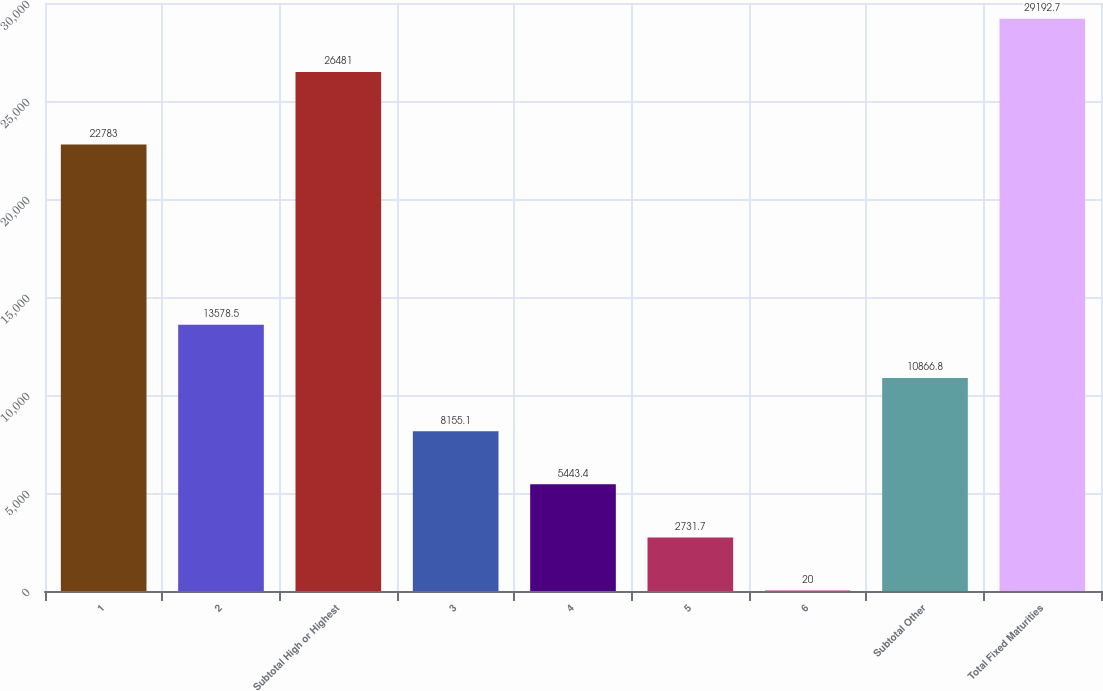Convert chart to OTSL. <chart><loc_0><loc_0><loc_500><loc_500><bar_chart><fcel>1<fcel>2<fcel>Subtotal High or Highest<fcel>3<fcel>4<fcel>5<fcel>6<fcel>Subtotal Other<fcel>Total Fixed Maturities<nl><fcel>22783<fcel>13578.5<fcel>26481<fcel>8155.1<fcel>5443.4<fcel>2731.7<fcel>20<fcel>10866.8<fcel>29192.7<nl></chart> 